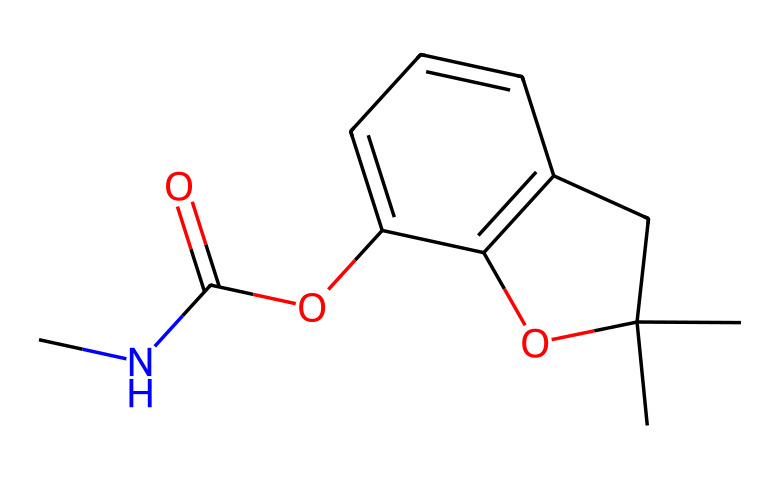What is the molecular weight of carbofuran? To calculate the molecular weight, we sum the atomic weights of all atoms in the compound shown in the SMILES notation. The molecular formula can be derived as C13H15N1O3, and after calculation, the result comes to about 225.27 g/mol.
Answer: 225.27 g/mol How many carbon atoms are in carbofuran? By analyzing the SMILES representation, we can count the number of carbon atoms present. The structure indicates a total of 13 carbon atoms.
Answer: 13 What type of functional group is present in carbofuran? The SMILES notation includes a carbamate (C(=O)O-) functional group, which is characterized by a carbonyl (C=O) connected to an oxygen atom.
Answer: carbamate Which part of the chemical indicates its nitrogen atom? In the SMILES notation, the 'N' letter represents the nitrogen atom present in carbofuran. Thus, the 'N' in the structure indicates its position.
Answer: N What is the primary use of carbofuran in agriculture? Carbofuran is primarily used as a pesticide for protecting crops such as rice from insect pests and nematodes.
Answer: pesticide How many oxygen atoms are present in carbofuran? By examining the molecular structure derived from the SMILES notation, it can be counted that there are 3 oxygen atoms present in carbofuran.
Answer: 3 